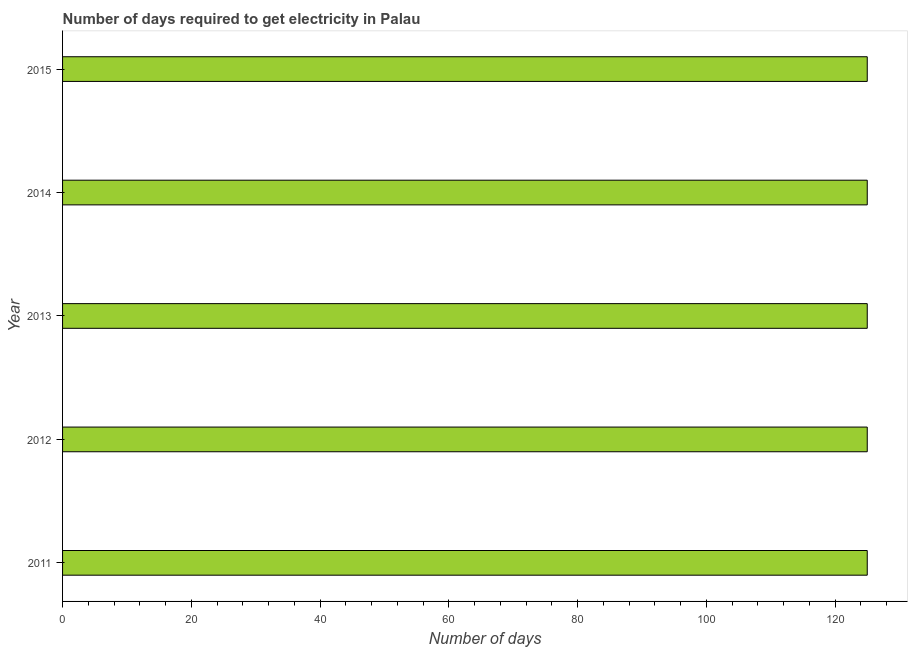What is the title of the graph?
Keep it short and to the point. Number of days required to get electricity in Palau. What is the label or title of the X-axis?
Provide a succinct answer. Number of days. What is the label or title of the Y-axis?
Offer a terse response. Year. What is the time to get electricity in 2011?
Offer a terse response. 125. Across all years, what is the maximum time to get electricity?
Your answer should be very brief. 125. Across all years, what is the minimum time to get electricity?
Your answer should be compact. 125. In which year was the time to get electricity maximum?
Ensure brevity in your answer.  2011. What is the sum of the time to get electricity?
Your answer should be compact. 625. What is the average time to get electricity per year?
Offer a very short reply. 125. What is the median time to get electricity?
Your answer should be very brief. 125. In how many years, is the time to get electricity greater than 40 ?
Your response must be concise. 5. Do a majority of the years between 2011 and 2013 (inclusive) have time to get electricity greater than 36 ?
Provide a succinct answer. Yes. Is the difference between the time to get electricity in 2013 and 2014 greater than the difference between any two years?
Keep it short and to the point. Yes. What is the difference between the highest and the second highest time to get electricity?
Keep it short and to the point. 0. How many bars are there?
Your answer should be compact. 5. How many years are there in the graph?
Your answer should be compact. 5. Are the values on the major ticks of X-axis written in scientific E-notation?
Provide a succinct answer. No. What is the Number of days in 2011?
Give a very brief answer. 125. What is the Number of days of 2012?
Make the answer very short. 125. What is the Number of days of 2013?
Keep it short and to the point. 125. What is the Number of days of 2014?
Give a very brief answer. 125. What is the Number of days in 2015?
Provide a short and direct response. 125. What is the difference between the Number of days in 2011 and 2012?
Your answer should be compact. 0. What is the difference between the Number of days in 2011 and 2013?
Your response must be concise. 0. What is the difference between the Number of days in 2011 and 2014?
Provide a short and direct response. 0. What is the difference between the Number of days in 2011 and 2015?
Offer a terse response. 0. What is the difference between the Number of days in 2012 and 2013?
Provide a succinct answer. 0. What is the difference between the Number of days in 2013 and 2015?
Your answer should be very brief. 0. What is the ratio of the Number of days in 2011 to that in 2013?
Provide a short and direct response. 1. What is the ratio of the Number of days in 2012 to that in 2014?
Your answer should be compact. 1. What is the ratio of the Number of days in 2012 to that in 2015?
Offer a very short reply. 1. What is the ratio of the Number of days in 2013 to that in 2014?
Give a very brief answer. 1. What is the ratio of the Number of days in 2014 to that in 2015?
Provide a succinct answer. 1. 